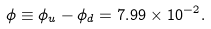<formula> <loc_0><loc_0><loc_500><loc_500>\phi \equiv \phi _ { u } - \phi _ { d } = 7 . 9 9 \times 1 0 ^ { - 2 } .</formula> 